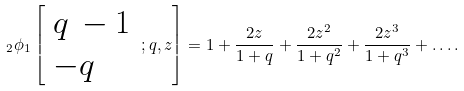<formula> <loc_0><loc_0><loc_500><loc_500>\, _ { 2 } \phi _ { 1 } \left [ { \begin{array} { l } { q \, - 1 } \\ { - q } \end{array} } \, ; q , z \right ] = 1 + { \frac { 2 z } { 1 + q } } + { \frac { 2 z ^ { 2 } } { 1 + q ^ { 2 } } } + { \frac { 2 z ^ { 3 } } { 1 + q ^ { 3 } } } + \dots .</formula> 